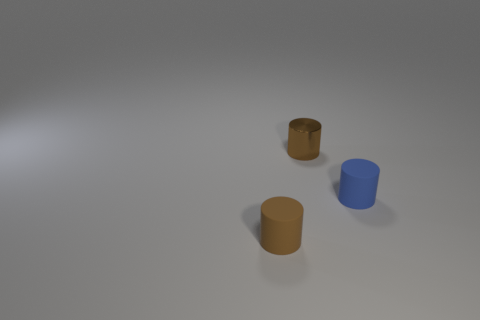What material is the blue cylinder?
Your response must be concise. Rubber. The brown metal thing that is the same shape as the tiny brown rubber thing is what size?
Make the answer very short. Small. How many other things are made of the same material as the tiny blue object?
Ensure brevity in your answer.  1. Is the number of tiny metallic cylinders that are right of the blue matte cylinder the same as the number of blue matte objects?
Your answer should be compact. No. There is a matte object that is left of the blue cylinder; is its size the same as the tiny brown metallic cylinder?
Your response must be concise. Yes. There is a brown shiny cylinder; what number of rubber cylinders are to the right of it?
Offer a very short reply. 1. What is the material of the tiny object that is to the left of the small blue cylinder and in front of the brown metallic thing?
Keep it short and to the point. Rubber. What number of tiny things are cyan metallic balls or cylinders?
Offer a terse response. 3. What size is the shiny thing?
Your answer should be compact. Small. Are there any other things that have the same shape as the small blue rubber thing?
Your answer should be compact. Yes. 